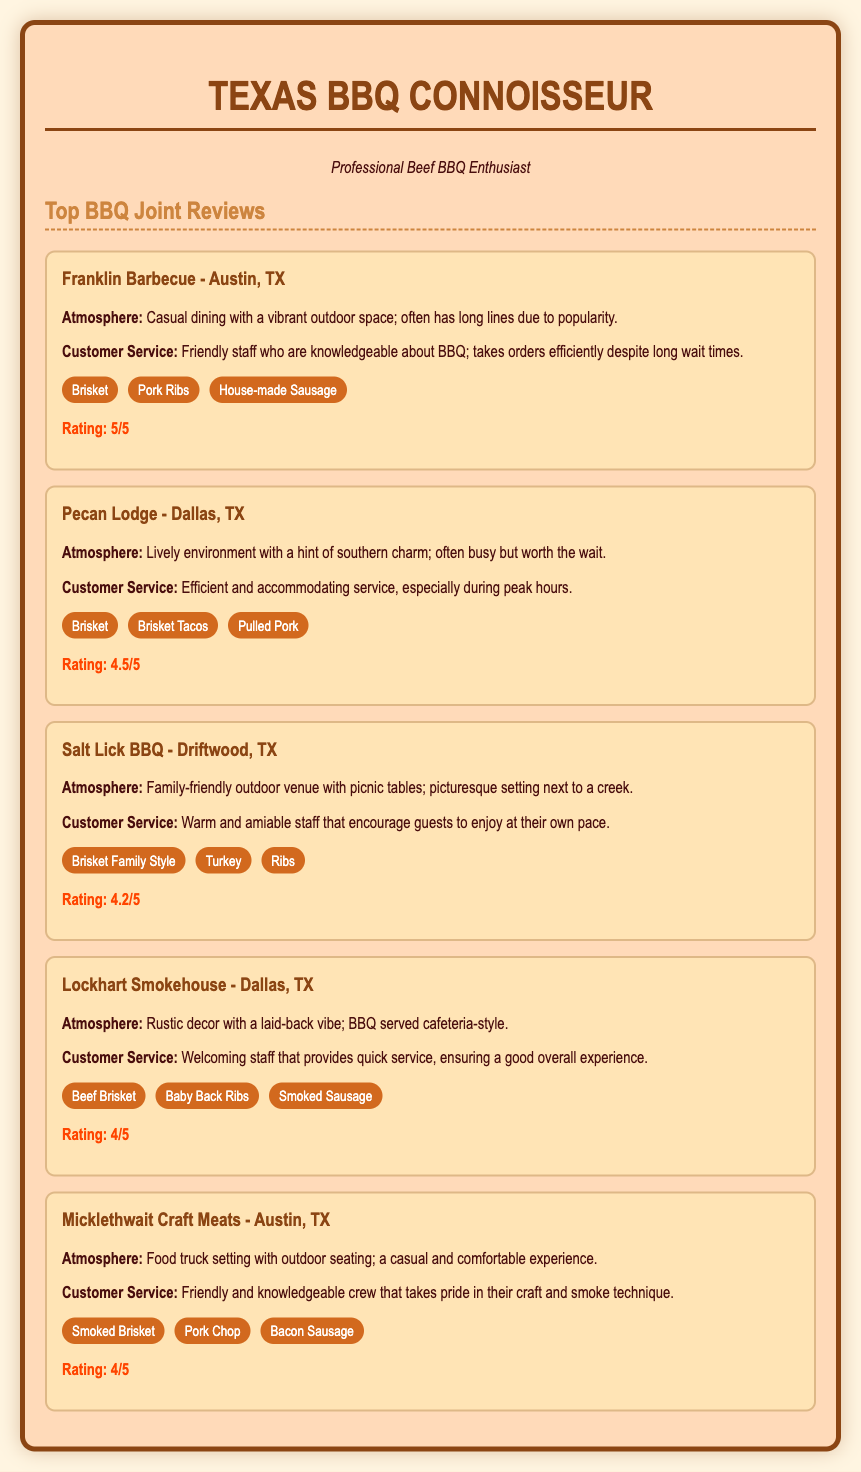What is the highest-rated BBQ joint? The highest-rated BBQ joint according to the document is Franklin Barbecue with a rating of 5/5.
Answer: Franklin Barbecue Which specialty is highlighted for Pecan Lodge? The document lists Brisket Tacos as one of the specialties highlighted for Pecan Lodge.
Answer: Brisket Tacos What type of service does Salt Lick BBQ offer? The customer service at Salt Lick BBQ is described as warm and amiable, encouraging guests to enjoy at their own pace.
Answer: Warm and amiable How many specialties are listed for Micklethwait Craft Meats? There are three specialties listed for Micklethwait Craft Meats in the document.
Answer: Three Which BBQ joint is noted for its rustic decor? Lockhart Smokehouse is noted for its rustic decor in the document.
Answer: Lockhart Smokehouse What is the atmosphere rating for Salt Lick BBQ? The atmosphere rating for Salt Lick BBQ is described as family-friendly.
Answer: Family-friendly Which BBQ joint is located in Driftwood, TX? The document states that Salt Lick BBQ is the joint located in Driftwood, TX.
Answer: Salt Lick BBQ What is a common feature of Franklin Barbecue's customer service? The document indicates that Franklin Barbecue's customer service is characterized by friendly and knowledgeable staff.
Answer: Friendly and knowledgeable staff 